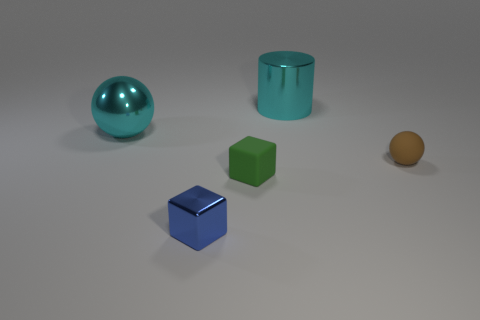Subtract all brown balls. How many balls are left? 1 Subtract all cylinders. How many objects are left? 4 Add 1 brown rubber things. How many objects exist? 6 Subtract 0 red blocks. How many objects are left? 5 Subtract all red cylinders. Subtract all cyan cubes. How many cylinders are left? 1 Subtract all green cylinders. How many blue blocks are left? 1 Subtract all small spheres. Subtract all large metallic objects. How many objects are left? 2 Add 2 matte objects. How many matte objects are left? 4 Add 1 brown spheres. How many brown spheres exist? 2 